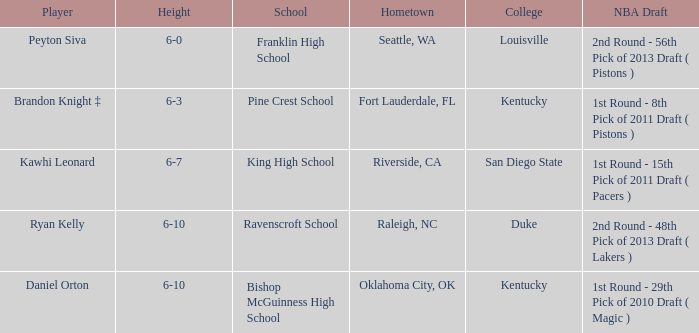Which college does Peyton Siva play for? Louisville. 